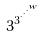Convert formula to latex. <formula><loc_0><loc_0><loc_500><loc_500>3 ^ { 3 ^ { \cdot ^ { \cdot ^ { \cdot ^ { w } } } } }</formula> 